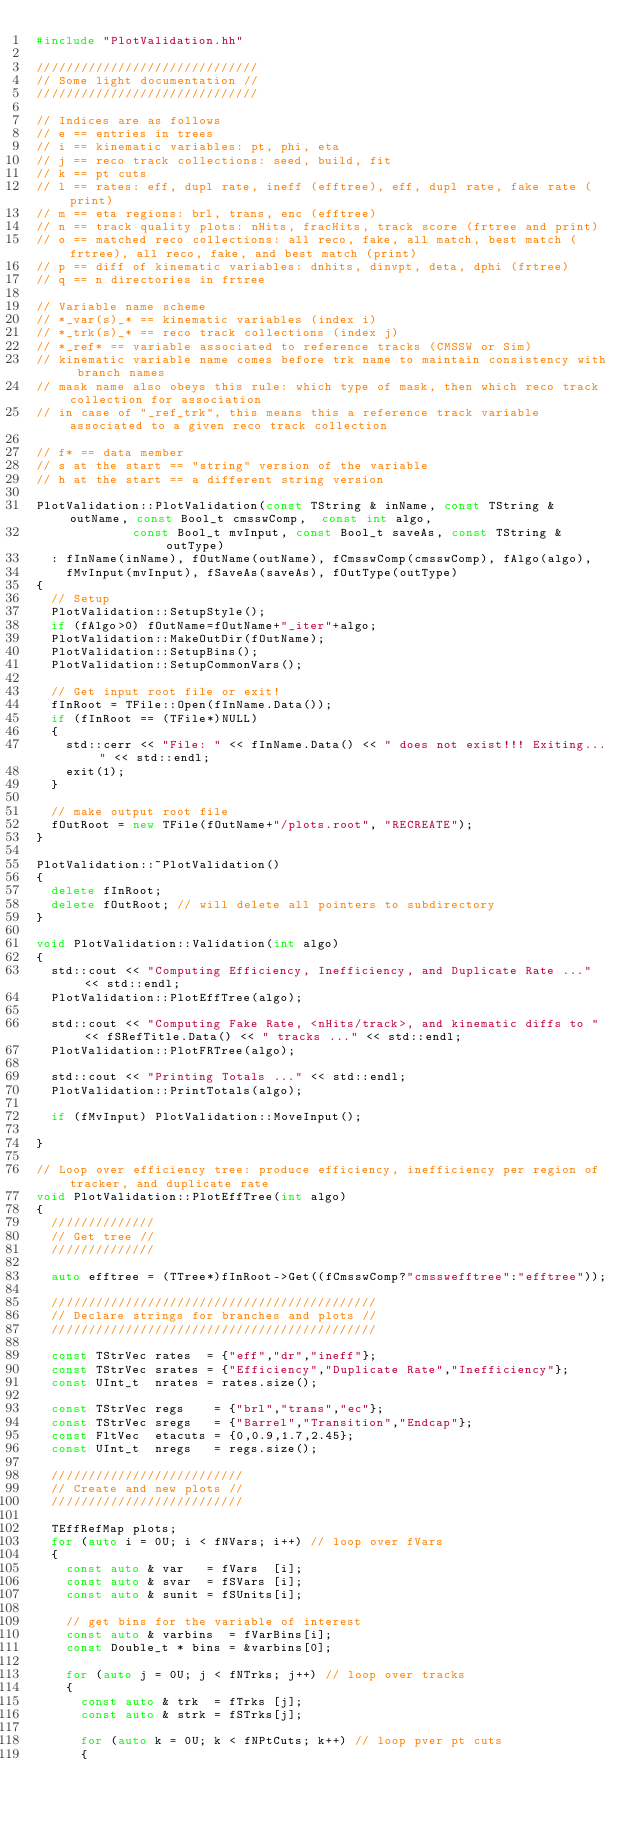Convert code to text. <code><loc_0><loc_0><loc_500><loc_500><_C++_>#include "PlotValidation.hh"

//////////////////////////////
// Some light documentation //
//////////////////////////////

// Indices are as follows
// e == entries in trees
// i == kinematic variables: pt, phi, eta
// j == reco track collections: seed, build, fit
// k == pt cuts
// l == rates: eff, dupl rate, ineff (efftree), eff, dupl rate, fake rate (print)
// m == eta regions: brl, trans, enc (efftree)
// n == track quality plots: nHits, fracHits, track score (frtree and print)
// o == matched reco collections: all reco, fake, all match, best match (frtree), all reco, fake, and best match (print)
// p == diff of kinematic variables: dnhits, dinvpt, deta, dphi (frtree)
// q == n directories in frtree

// Variable name scheme
// *_var(s)_* == kinematic variables (index i)
// *_trk(s)_* == reco track collections (index j)
// *_ref* == variable associated to reference tracks (CMSSW or Sim)
// kinematic variable name comes before trk name to maintain consistency with branch names
// mask name also obeys this rule: which type of mask, then which reco track collection for association
// in case of "_ref_trk", this means this a reference track variable associated to a given reco track collection

// f* == data member
// s at the start == "string" version of the variable
// h at the start == a different string version

PlotValidation::PlotValidation(const TString & inName, const TString & outName, const Bool_t cmsswComp,  const int algo,
			       const Bool_t mvInput, const Bool_t saveAs, const TString & outType)
  : fInName(inName), fOutName(outName), fCmsswComp(cmsswComp), fAlgo(algo),
    fMvInput(mvInput), fSaveAs(saveAs), fOutType(outType)
{
  // Setup 
  PlotValidation::SetupStyle();
  if (fAlgo>0) fOutName=fOutName+"_iter"+algo;
  PlotValidation::MakeOutDir(fOutName);
  PlotValidation::SetupBins();
  PlotValidation::SetupCommonVars();

  // Get input root file or exit!
  fInRoot = TFile::Open(fInName.Data());
  if (fInRoot == (TFile*)NULL)
  {
    std::cerr << "File: " << fInName.Data() << " does not exist!!! Exiting..." << std::endl;
    exit(1);
  }

  // make output root file
  fOutRoot = new TFile(fOutName+"/plots.root", "RECREATE");
}

PlotValidation::~PlotValidation()
{
  delete fInRoot;
  delete fOutRoot; // will delete all pointers to subdirectory
}

void PlotValidation::Validation(int algo)
{
  std::cout << "Computing Efficiency, Inefficiency, and Duplicate Rate ..." << std::endl;
  PlotValidation::PlotEffTree(algo);
  
  std::cout << "Computing Fake Rate, <nHits/track>, and kinematic diffs to " << fSRefTitle.Data() << " tracks ..." << std::endl;
  PlotValidation::PlotFRTree(algo);
  
  std::cout << "Printing Totals ..." << std::endl;
  PlotValidation::PrintTotals(algo);
  
  if (fMvInput) PlotValidation::MoveInput();
  
}

// Loop over efficiency tree: produce efficiency, inefficiency per region of tracker, and duplicate rate
void PlotValidation::PlotEffTree(int algo)
{
  //////////////
  // Get tree //
  //////////////

  auto efftree = (TTree*)fInRoot->Get((fCmsswComp?"cmsswefftree":"efftree"));

  ////////////////////////////////////////////
  // Declare strings for branches and plots //
  ////////////////////////////////////////////

  const TStrVec rates  = {"eff","dr","ineff"};
  const TStrVec srates = {"Efficiency","Duplicate Rate","Inefficiency"}; 
  const UInt_t  nrates = rates.size();

  const TStrVec regs    = {"brl","trans","ec"};
  const TStrVec sregs   = {"Barrel","Transition","Endcap"};
  const FltVec  etacuts = {0,0.9,1.7,2.45};
  const UInt_t  nregs   = regs.size();

  //////////////////////////
  // Create and new plots //
  //////////////////////////

  TEffRefMap plots;
  for (auto i = 0U; i < fNVars; i++) // loop over fVars
  {
    const auto & var   = fVars  [i];
    const auto & svar  = fSVars [i];
    const auto & sunit = fSUnits[i];

    // get bins for the variable of interest
    const auto & varbins  = fVarBins[i];
    const Double_t * bins = &varbins[0];

    for (auto j = 0U; j < fNTrks; j++) // loop over tracks
    {
      const auto & trk  = fTrks [j];
      const auto & strk = fSTrks[j];
      
      for (auto k = 0U; k < fNPtCuts; k++) // loop pver pt cuts
      {</code> 